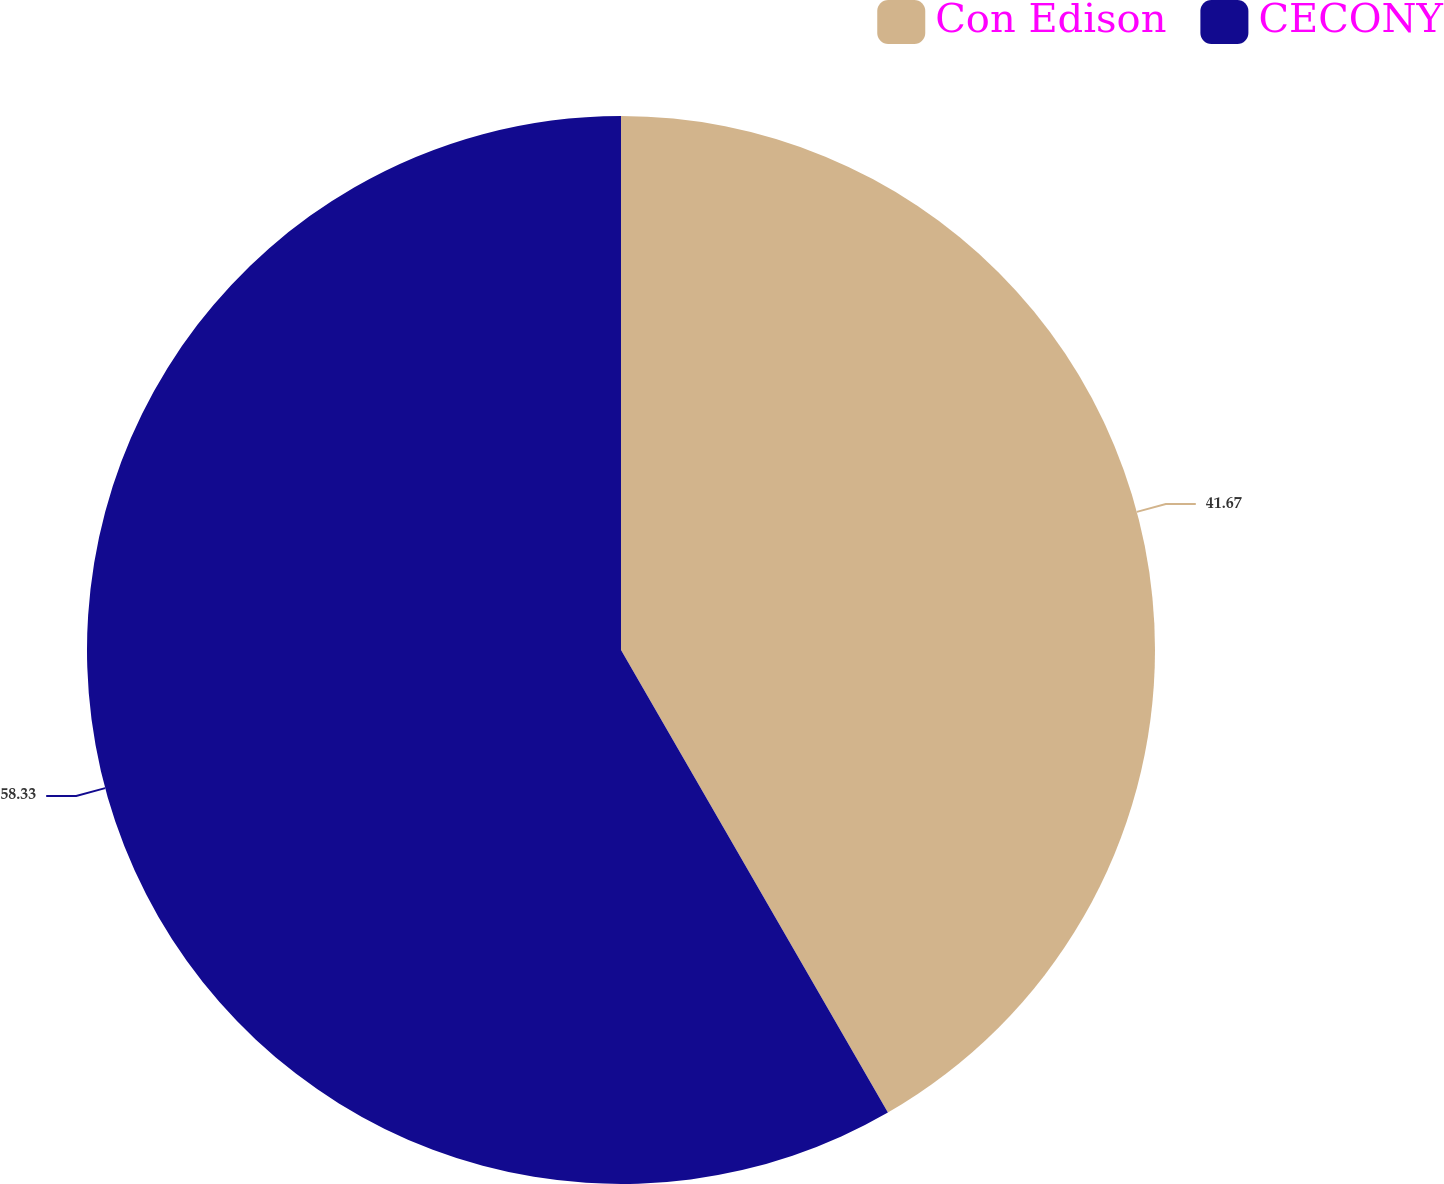Convert chart. <chart><loc_0><loc_0><loc_500><loc_500><pie_chart><fcel>Con Edison<fcel>CECONY<nl><fcel>41.67%<fcel>58.33%<nl></chart> 